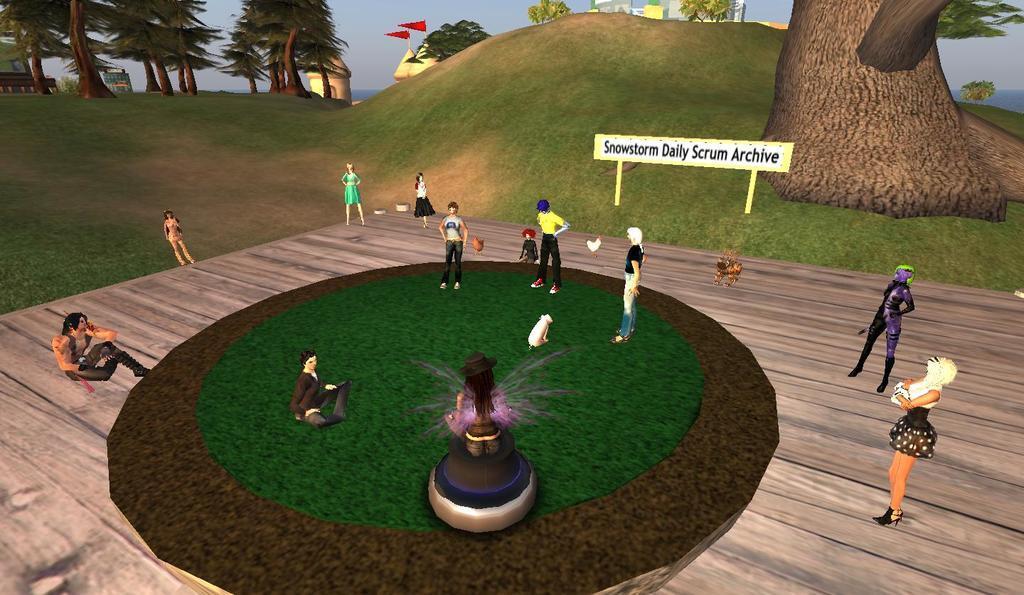Please provide a concise description of this image. This is an animated picture. In the foreground of the picture there are many people, fountain, animals, boat, grass and other objects. On the right there is a tree. In the background there are trees, castle, building, sky, water body and other objects. 